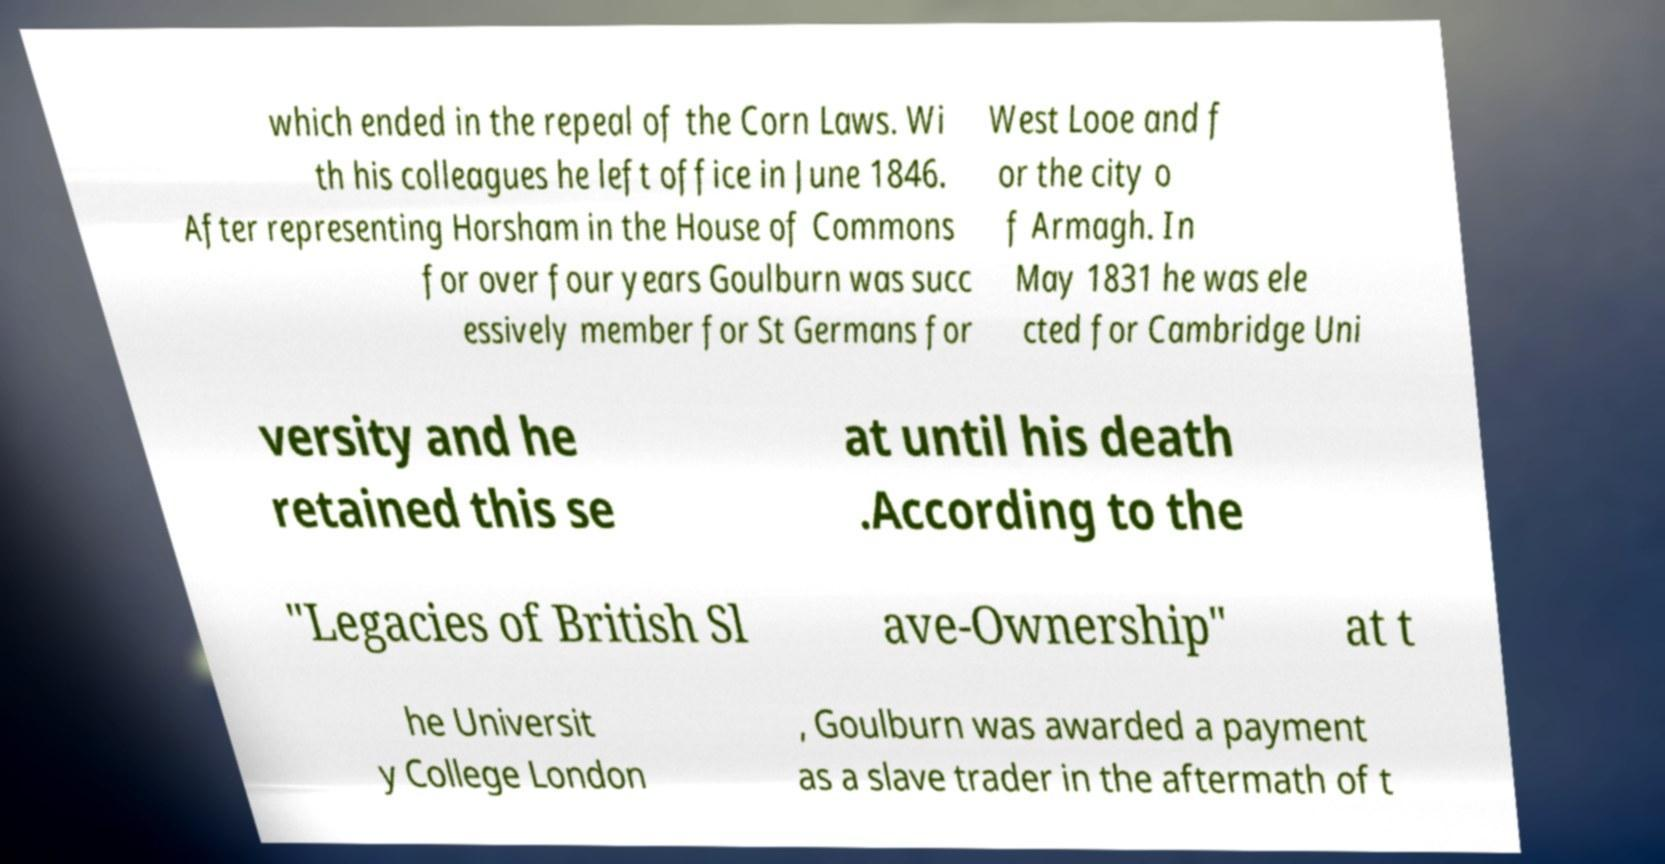Could you assist in decoding the text presented in this image and type it out clearly? which ended in the repeal of the Corn Laws. Wi th his colleagues he left office in June 1846. After representing Horsham in the House of Commons for over four years Goulburn was succ essively member for St Germans for West Looe and f or the city o f Armagh. In May 1831 he was ele cted for Cambridge Uni versity and he retained this se at until his death .According to the "Legacies of British Sl ave-Ownership" at t he Universit y College London , Goulburn was awarded a payment as a slave trader in the aftermath of t 